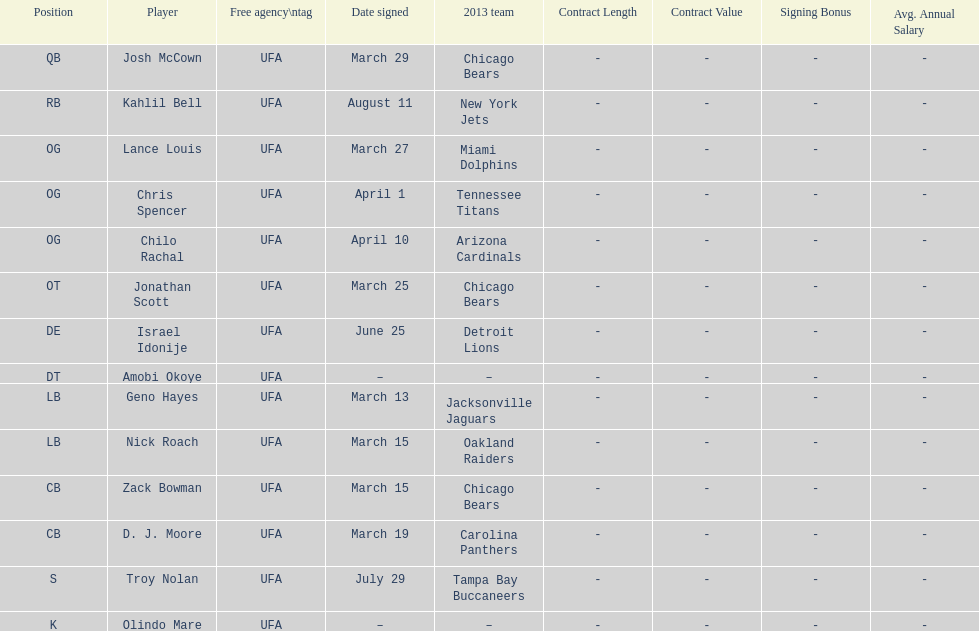Who was the previous player signed before troy nolan? Israel Idonije. I'm looking to parse the entire table for insights. Could you assist me with that? {'header': ['Position', 'Player', 'Free agency\\ntag', 'Date signed', '2013 team', 'Contract Length', 'Contract Value', 'Signing Bonus', 'Avg. Annual Salary'], 'rows': [['QB', 'Josh McCown', 'UFA', 'March 29', 'Chicago Bears', '-', '-', '-', '-'], ['RB', 'Kahlil Bell', 'UFA', 'August 11', 'New York Jets', '-', '-', '-', '-'], ['OG', 'Lance Louis', 'UFA', 'March 27', 'Miami Dolphins', '-', '-', '-', '-'], ['OG', 'Chris Spencer', 'UFA', 'April 1', 'Tennessee Titans', '-', '-', '-', '-'], ['OG', 'Chilo Rachal', 'UFA', 'April 10', 'Arizona Cardinals', '-', '-', '-', '-'], ['OT', 'Jonathan Scott', 'UFA', 'March 25', 'Chicago Bears', '-', '-', '-', '-'], ['DE', 'Israel Idonije', 'UFA', 'June 25', 'Detroit Lions', '-', '-', '-', '-'], ['DT', 'Amobi Okoye', 'UFA', '–', '–', '-', '-', '-', '-'], ['LB', 'Geno Hayes', 'UFA', 'March 13', 'Jacksonville Jaguars', '-', '-', '-', '-'], ['LB', 'Nick Roach', 'UFA', 'March 15', 'Oakland Raiders', '-', '-', '-', '-'], ['CB', 'Zack Bowman', 'UFA', 'March 15', 'Chicago Bears', '-', '-', '-', '-'], ['CB', 'D. J. Moore', 'UFA', 'March 19', 'Carolina Panthers', '-', '-', '-', '-'], ['S', 'Troy Nolan', 'UFA', 'July 29', 'Tampa Bay Buccaneers', '-', '-', '-', '-'], ['K', 'Olindo Mare', 'UFA', '–', '–', '-', '-', '-', '-']]} 